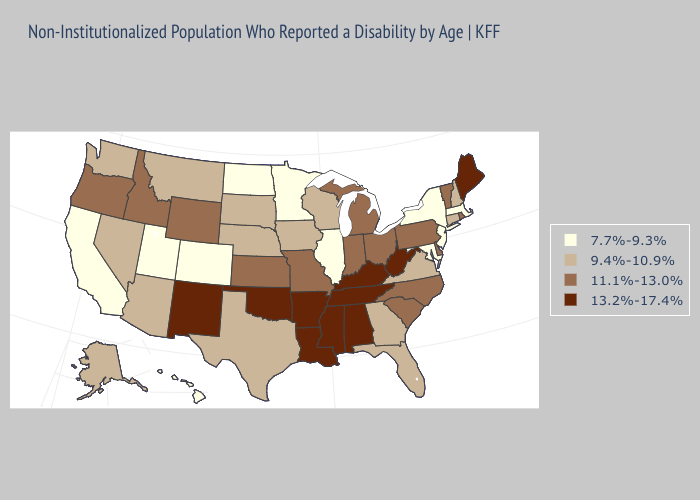Does Delaware have the highest value in the USA?
Short answer required. No. Does Ohio have a higher value than West Virginia?
Answer briefly. No. What is the lowest value in the Northeast?
Quick response, please. 7.7%-9.3%. Among the states that border Wisconsin , which have the highest value?
Be succinct. Michigan. What is the value of Missouri?
Quick response, please. 11.1%-13.0%. Among the states that border North Carolina , does South Carolina have the lowest value?
Quick response, please. No. What is the lowest value in the USA?
Give a very brief answer. 7.7%-9.3%. Does North Dakota have the highest value in the MidWest?
Answer briefly. No. Name the states that have a value in the range 13.2%-17.4%?
Quick response, please. Alabama, Arkansas, Kentucky, Louisiana, Maine, Mississippi, New Mexico, Oklahoma, Tennessee, West Virginia. What is the highest value in the USA?
Short answer required. 13.2%-17.4%. Name the states that have a value in the range 13.2%-17.4%?
Keep it brief. Alabama, Arkansas, Kentucky, Louisiana, Maine, Mississippi, New Mexico, Oklahoma, Tennessee, West Virginia. Which states have the highest value in the USA?
Keep it brief. Alabama, Arkansas, Kentucky, Louisiana, Maine, Mississippi, New Mexico, Oklahoma, Tennessee, West Virginia. What is the lowest value in the USA?
Write a very short answer. 7.7%-9.3%. How many symbols are there in the legend?
Answer briefly. 4. 